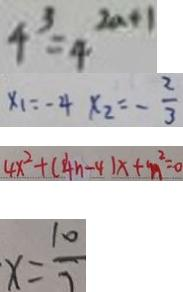Convert formula to latex. <formula><loc_0><loc_0><loc_500><loc_500>4 ^ { 3 } = 4 ^ { 2 n + 1 } 
 x _ { 1 } = - 4 x _ { 2 } = - \frac { 2 } { 3 } 
 4 x ^ { 2 } + ( 4 n - 4 ) x + n ^ { 2 } = 0 
 x = \frac { 1 0 } { 7 }</formula> 